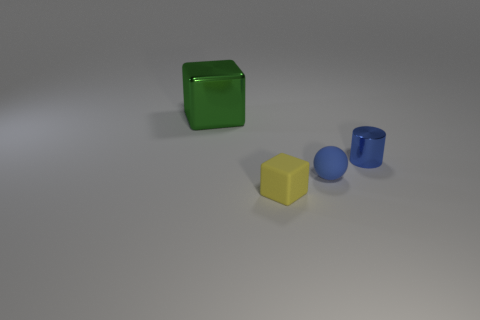There is a tiny matte thing that is behind the tiny thing on the left side of the small blue rubber ball; what color is it?
Offer a terse response. Blue. There is another object that is the same shape as the green shiny object; what color is it?
Ensure brevity in your answer.  Yellow. What number of rubber spheres are the same color as the cylinder?
Offer a very short reply. 1. Is the color of the large thing the same as the small matte object to the left of the tiny blue matte thing?
Offer a terse response. No. What shape is the small thing that is to the right of the tiny matte cube and in front of the tiny metal cylinder?
Offer a very short reply. Sphere. There is a cube right of the thing that is to the left of the block on the right side of the large thing; what is its material?
Your response must be concise. Rubber. Is the number of small yellow matte blocks right of the tiny block greater than the number of small metal cylinders that are right of the blue shiny object?
Your answer should be compact. No. What number of cubes are made of the same material as the green thing?
Give a very brief answer. 0. There is a metal object to the right of the large green thing; does it have the same shape as the object that is in front of the blue rubber sphere?
Offer a terse response. No. What is the color of the thing that is on the left side of the tiny block?
Keep it short and to the point. Green. 